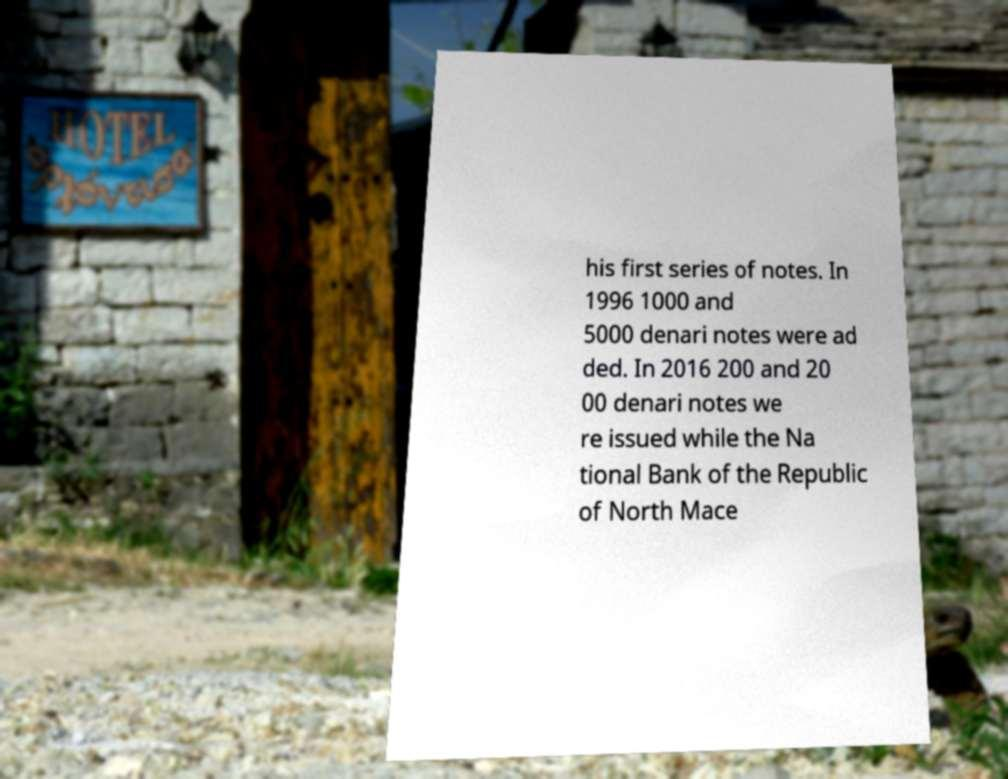There's text embedded in this image that I need extracted. Can you transcribe it verbatim? his first series of notes. In 1996 1000 and 5000 denari notes were ad ded. In 2016 200 and 20 00 denari notes we re issued while the Na tional Bank of the Republic of North Mace 